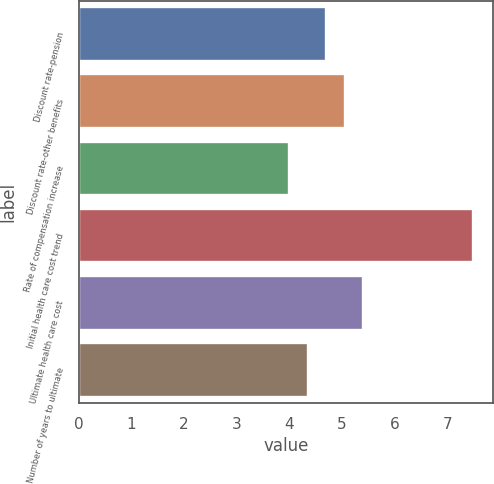<chart> <loc_0><loc_0><loc_500><loc_500><bar_chart><fcel>Discount rate-pension<fcel>Discount rate-other benefits<fcel>Rate of compensation increase<fcel>Initial health care cost trend<fcel>Ultimate health care cost<fcel>Number of years to ultimate<nl><fcel>4.7<fcel>5.05<fcel>4<fcel>7.5<fcel>5.4<fcel>4.35<nl></chart> 